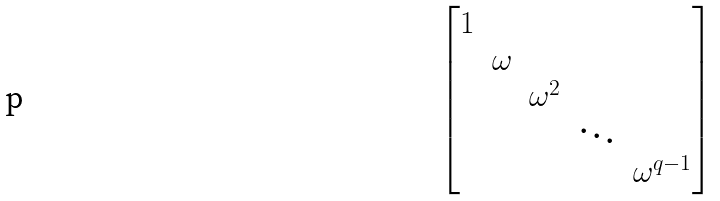Convert formula to latex. <formula><loc_0><loc_0><loc_500><loc_500>\begin{bmatrix} 1 & & & & \\ & \omega & & & \\ & & \omega ^ { 2 } & & \\ & & & \ddots & \\ & & & & \omega ^ { q - 1 } \end{bmatrix}</formula> 